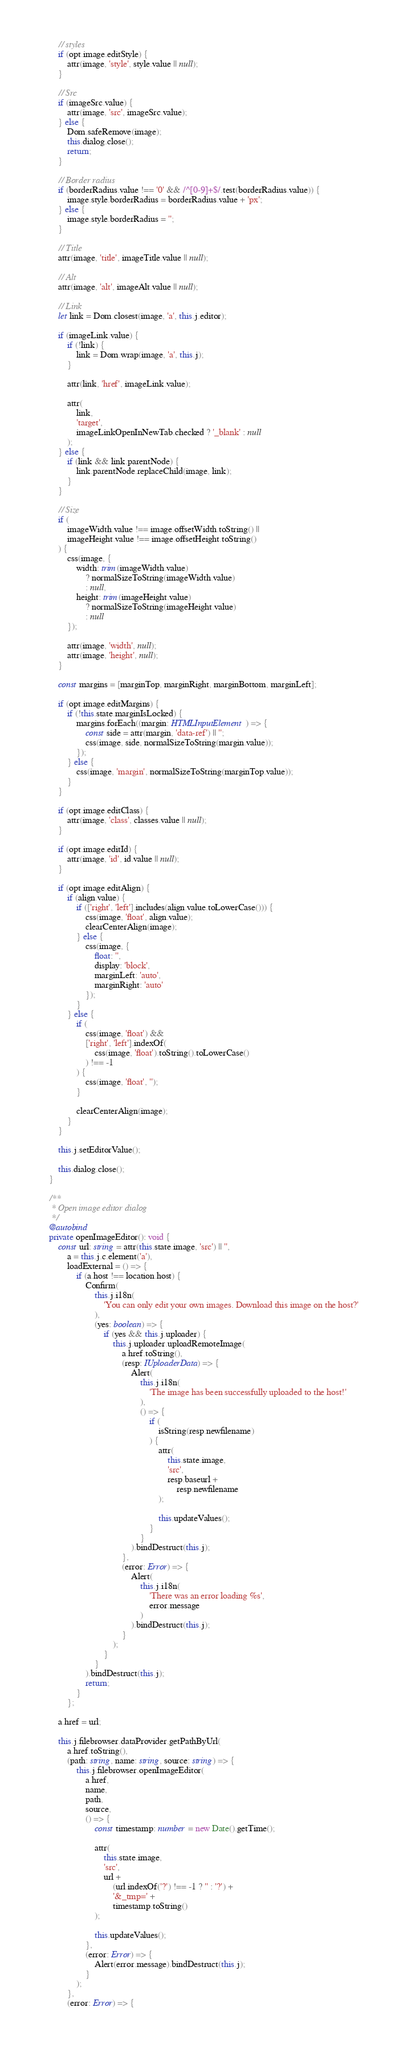Convert code to text. <code><loc_0><loc_0><loc_500><loc_500><_TypeScript_>
		// styles
		if (opt.image.editStyle) {
			attr(image, 'style', style.value || null);
		}

		// Src
		if (imageSrc.value) {
			attr(image, 'src', imageSrc.value);
		} else {
			Dom.safeRemove(image);
			this.dialog.close();
			return;
		}

		// Border radius
		if (borderRadius.value !== '0' && /^[0-9]+$/.test(borderRadius.value)) {
			image.style.borderRadius = borderRadius.value + 'px';
		} else {
			image.style.borderRadius = '';
		}

		// Title
		attr(image, 'title', imageTitle.value || null);

		// Alt
		attr(image, 'alt', imageAlt.value || null);

		// Link
		let link = Dom.closest(image, 'a', this.j.editor);

		if (imageLink.value) {
			if (!link) {
				link = Dom.wrap(image, 'a', this.j);
			}

			attr(link, 'href', imageLink.value);

			attr(
				link,
				'target',
				imageLinkOpenInNewTab.checked ? '_blank' : null
			);
		} else {
			if (link && link.parentNode) {
				link.parentNode.replaceChild(image, link);
			}
		}

		// Size
		if (
			imageWidth.value !== image.offsetWidth.toString() ||
			imageHeight.value !== image.offsetHeight.toString()
		) {
			css(image, {
				width: trim(imageWidth.value)
					? normalSizeToString(imageWidth.value)
					: null,
				height: trim(imageHeight.value)
					? normalSizeToString(imageHeight.value)
					: null
			});

			attr(image, 'width', null);
			attr(image, 'height', null);
		}

		const margins = [marginTop, marginRight, marginBottom, marginLeft];

		if (opt.image.editMargins) {
			if (!this.state.marginIsLocked) {
				margins.forEach((margin: HTMLInputElement) => {
					const side = attr(margin, 'data-ref') || '';
					css(image, side, normalSizeToString(margin.value));
				});
			} else {
				css(image, 'margin', normalSizeToString(marginTop.value));
			}
		}

		if (opt.image.editClass) {
			attr(image, 'class', classes.value || null);
		}

		if (opt.image.editId) {
			attr(image, 'id', id.value || null);
		}

		if (opt.image.editAlign) {
			if (align.value) {
				if (['right', 'left'].includes(align.value.toLowerCase())) {
					css(image, 'float', align.value);
					clearCenterAlign(image);
				} else {
					css(image, {
						float: '',
						display: 'block',
						marginLeft: 'auto',
						marginRight: 'auto'
					});
				}
			} else {
				if (
					css(image, 'float') &&
					['right', 'left'].indexOf(
						css(image, 'float').toString().toLowerCase()
					) !== -1
				) {
					css(image, 'float', '');
				}

				clearCenterAlign(image);
			}
		}

		this.j.setEditorValue();

		this.dialog.close();
	}

	/**
	 * Open image editor dialog
	 */
	@autobind
	private openImageEditor(): void {
		const url: string = attr(this.state.image, 'src') || '',
			a = this.j.c.element('a'),
			loadExternal = () => {
				if (a.host !== location.host) {
					Confirm(
						this.j.i18n(
							'You can only edit your own images. Download this image on the host?'
						),
						(yes: boolean) => {
							if (yes && this.j.uploader) {
								this.j.uploader.uploadRemoteImage(
									a.href.toString(),
									(resp: IUploaderData) => {
										Alert(
											this.j.i18n(
												'The image has been successfully uploaded to the host!'
											),
											() => {
												if (
													isString(resp.newfilename)
												) {
													attr(
														this.state.image,
														'src',
														resp.baseurl +
															resp.newfilename
													);

													this.updateValues();
												}
											}
										).bindDestruct(this.j);
									},
									(error: Error) => {
										Alert(
											this.j.i18n(
												'There was an error loading %s',
												error.message
											)
										).bindDestruct(this.j);
									}
								);
							}
						}
					).bindDestruct(this.j);
					return;
				}
			};

		a.href = url;

		this.j.filebrowser.dataProvider.getPathByUrl(
			a.href.toString(),
			(path: string, name: string, source: string) => {
				this.j.filebrowser.openImageEditor(
					a.href,
					name,
					path,
					source,
					() => {
						const timestamp: number = new Date().getTime();

						attr(
							this.state.image,
							'src',
							url +
								(url.indexOf('?') !== -1 ? '' : '?') +
								'&_tmp=' +
								timestamp.toString()
						);

						this.updateValues();
					},
					(error: Error) => {
						Alert(error.message).bindDestruct(this.j);
					}
				);
			},
			(error: Error) => {</code> 